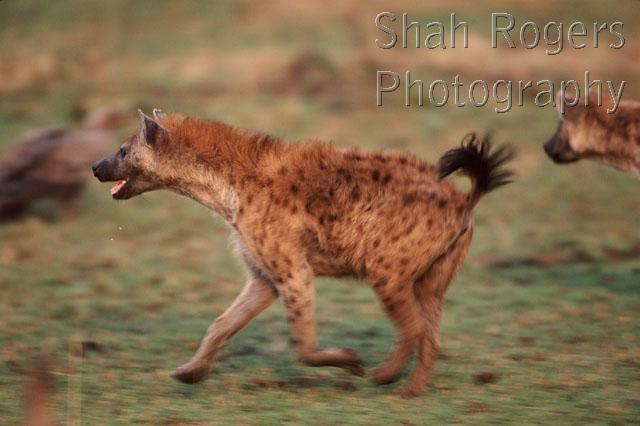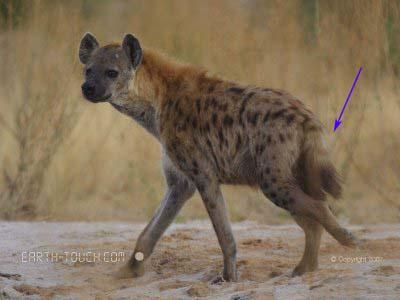The first image is the image on the left, the second image is the image on the right. Analyze the images presented: Is the assertion "There are a total of 3 hyena's." valid? Answer yes or no. Yes. The first image is the image on the left, the second image is the image on the right. Considering the images on both sides, is "There are 2 animals facing opposite directions in the right image." valid? Answer yes or no. No. 